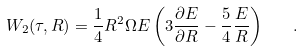<formula> <loc_0><loc_0><loc_500><loc_500>W _ { 2 } ( \tau , R ) = \frac { 1 } { 4 } R ^ { 2 } \Omega E \left ( 3 \frac { \partial E } { \partial R } - \frac { 5 } { 4 } \frac { E } { R } \right ) \quad .</formula> 